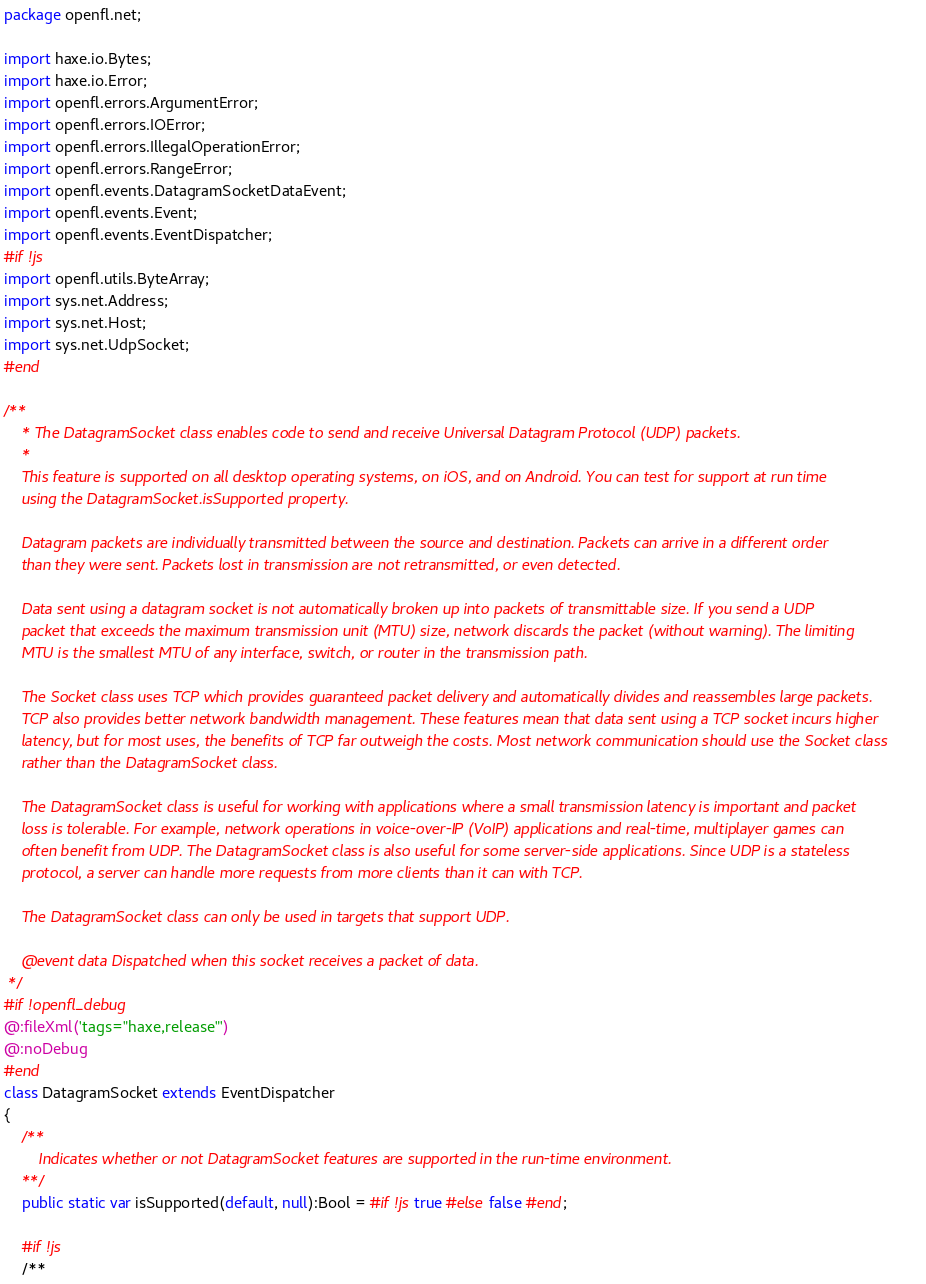<code> <loc_0><loc_0><loc_500><loc_500><_Haxe_>package openfl.net;

import haxe.io.Bytes;
import haxe.io.Error;
import openfl.errors.ArgumentError;
import openfl.errors.IOError;
import openfl.errors.IllegalOperationError;
import openfl.errors.RangeError;
import openfl.events.DatagramSocketDataEvent;
import openfl.events.Event;
import openfl.events.EventDispatcher;
#if !js
import openfl.utils.ByteArray;
import sys.net.Address;
import sys.net.Host;
import sys.net.UdpSocket;
#end

/**
	* The DatagramSocket class enables code to send and receive Universal Datagram Protocol (UDP) packets.
	*
	This feature is supported on all desktop operating systems, on iOS, and on Android. You can test for support at run time
	using the DatagramSocket.isSupported property.

	Datagram packets are individually transmitted between the source and destination. Packets can arrive in a different order
	than they were sent. Packets lost in transmission are not retransmitted, or even detected.

	Data sent using a datagram socket is not automatically broken up into packets of transmittable size. If you send a UDP
	packet that exceeds the maximum transmission unit (MTU) size, network discards the packet (without warning). The limiting
	MTU is the smallest MTU of any interface, switch, or router in the transmission path.

	The Socket class uses TCP which provides guaranteed packet delivery and automatically divides and reassembles large packets.
	TCP also provides better network bandwidth management. These features mean that data sent using a TCP socket incurs higher
	latency, but for most uses, the benefits of TCP far outweigh the costs. Most network communication should use the Socket class
	rather than the DatagramSocket class.

	The DatagramSocket class is useful for working with applications where a small transmission latency is important and packet
	loss is tolerable. For example, network operations in voice-over-IP (VoIP) applications and real-time, multiplayer games can
	often benefit from UDP. The DatagramSocket class is also useful for some server-side applications. Since UDP is a stateless
	protocol, a server can handle more requests from more clients than it can with TCP.

	The DatagramSocket class can only be used in targets that support UDP.

	@event data Dispatched when this socket receives a packet of data.
 */
#if !openfl_debug
@:fileXml('tags="haxe,release"')
@:noDebug
#end
class DatagramSocket extends EventDispatcher
{
	/**
		Indicates whether or not DatagramSocket features are supported in the run-time environment.
	**/
	public static var isSupported(default, null):Bool = #if !js true #else false #end;

	#if !js
	/**</code> 